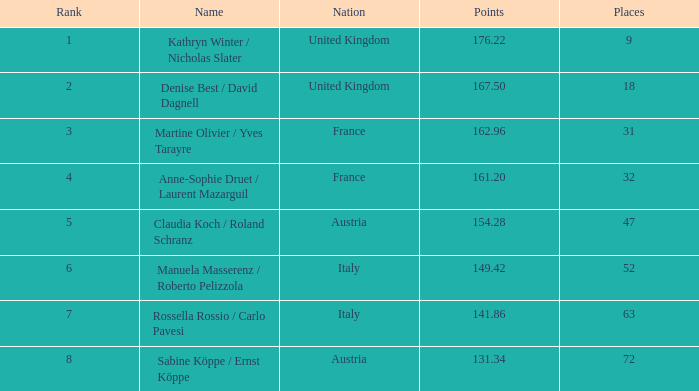Who has points larger than 167.5? Kathryn Winter / Nicholas Slater. Can you parse all the data within this table? {'header': ['Rank', 'Name', 'Nation', 'Points', 'Places'], 'rows': [['1', 'Kathryn Winter / Nicholas Slater', 'United Kingdom', '176.22', '9'], ['2', 'Denise Best / David Dagnell', 'United Kingdom', '167.50', '18'], ['3', 'Martine Olivier / Yves Tarayre', 'France', '162.96', '31'], ['4', 'Anne-Sophie Druet / Laurent Mazarguil', 'France', '161.20', '32'], ['5', 'Claudia Koch / Roland Schranz', 'Austria', '154.28', '47'], ['6', 'Manuela Masserenz / Roberto Pelizzola', 'Italy', '149.42', '52'], ['7', 'Rossella Rossio / Carlo Pavesi', 'Italy', '141.86', '63'], ['8', 'Sabine Köppe / Ernst Köppe', 'Austria', '131.34', '72']]} 